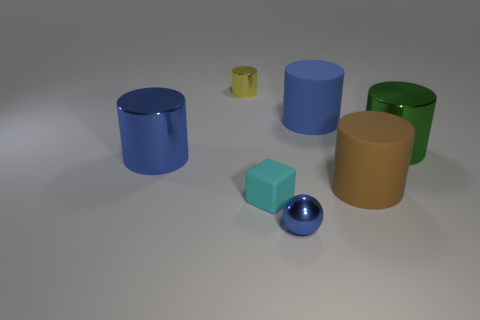Do the large cylinder left of the blue matte object and the big green cylinder have the same material?
Your answer should be compact. Yes. Are there any big brown matte cylinders?
Offer a very short reply. Yes. There is a matte object that is behind the small cube and in front of the big blue rubber cylinder; what size is it?
Keep it short and to the point. Large. Is the number of big brown matte things that are in front of the yellow cylinder greater than the number of blue rubber cylinders that are on the right side of the brown rubber cylinder?
Provide a short and direct response. Yes. What size is the matte thing that is the same color as the small metallic sphere?
Your answer should be compact. Large. What is the color of the small rubber object?
Ensure brevity in your answer.  Cyan. There is a shiny thing that is behind the brown object and to the right of the tiny metallic cylinder; what color is it?
Provide a short and direct response. Green. There is a big rubber thing behind the big rubber cylinder in front of the big cylinder right of the brown rubber cylinder; what is its color?
Your response must be concise. Blue. What is the color of the other metal thing that is the same size as the yellow thing?
Give a very brief answer. Blue. What is the shape of the small metal object in front of the large blue cylinder in front of the shiny object that is to the right of the tiny blue metallic object?
Keep it short and to the point. Sphere. 